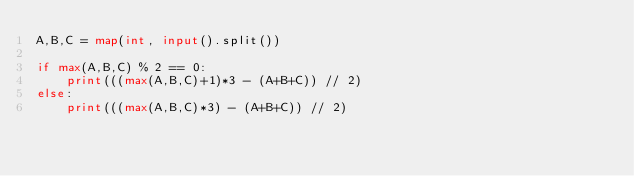<code> <loc_0><loc_0><loc_500><loc_500><_Python_>A,B,C = map(int, input().split())

if max(A,B,C) % 2 == 0:
    print(((max(A,B,C)+1)*3 - (A+B+C)) // 2)
else:
    print(((max(A,B,C)*3) - (A+B+C)) // 2)</code> 